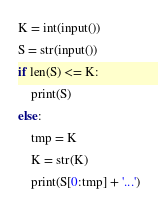<code> <loc_0><loc_0><loc_500><loc_500><_Python_>K = int(input())
S = str(input())
if len(S) <= K:
    print(S)
else:
    tmp = K
    K = str(K)
    print(S[0:tmp] + '...')</code> 